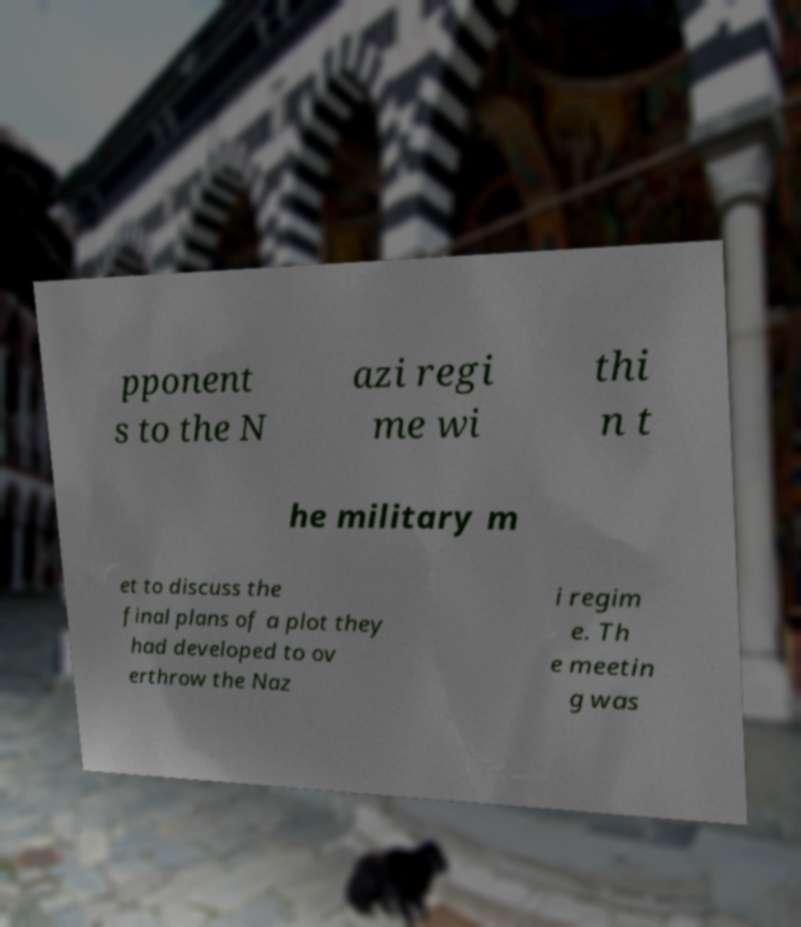There's text embedded in this image that I need extracted. Can you transcribe it verbatim? pponent s to the N azi regi me wi thi n t he military m et to discuss the final plans of a plot they had developed to ov erthrow the Naz i regim e. Th e meetin g was 